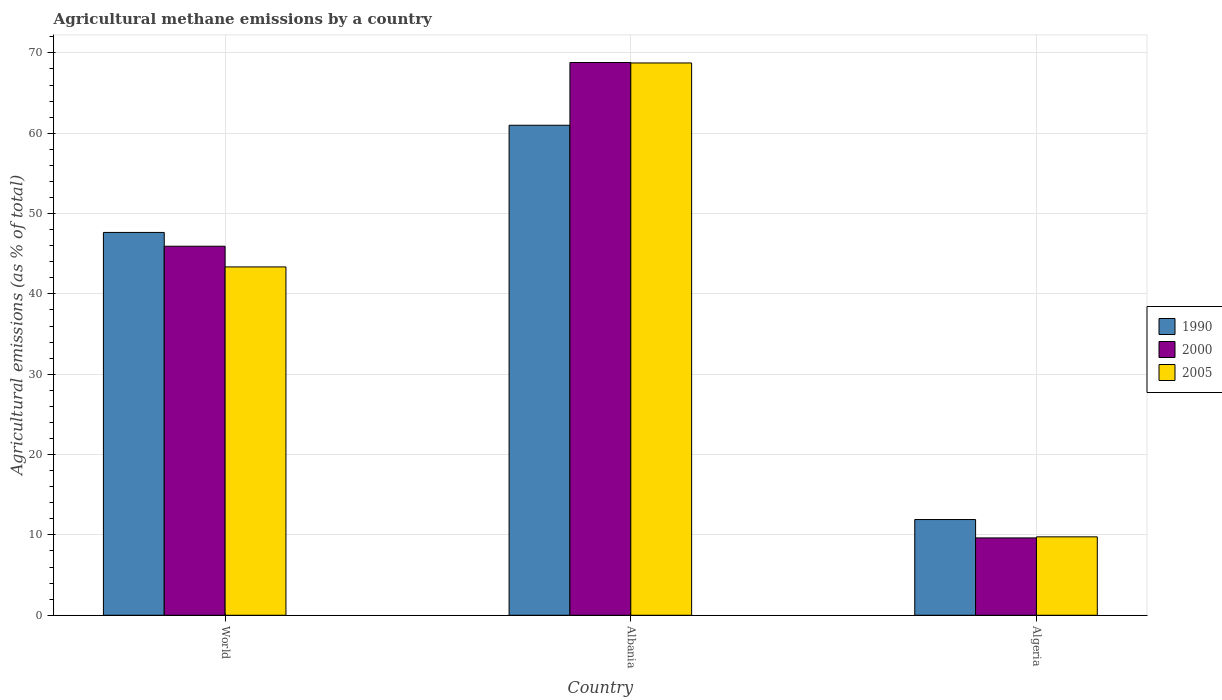How many different coloured bars are there?
Your answer should be very brief. 3. Are the number of bars per tick equal to the number of legend labels?
Provide a succinct answer. Yes. Are the number of bars on each tick of the X-axis equal?
Ensure brevity in your answer.  Yes. How many bars are there on the 1st tick from the left?
Ensure brevity in your answer.  3. How many bars are there on the 1st tick from the right?
Keep it short and to the point. 3. In how many cases, is the number of bars for a given country not equal to the number of legend labels?
Offer a very short reply. 0. What is the amount of agricultural methane emitted in 1990 in Algeria?
Give a very brief answer. 11.91. Across all countries, what is the maximum amount of agricultural methane emitted in 2000?
Your answer should be compact. 68.8. Across all countries, what is the minimum amount of agricultural methane emitted in 2000?
Your answer should be very brief. 9.63. In which country was the amount of agricultural methane emitted in 1990 maximum?
Keep it short and to the point. Albania. In which country was the amount of agricultural methane emitted in 2005 minimum?
Your response must be concise. Algeria. What is the total amount of agricultural methane emitted in 2005 in the graph?
Keep it short and to the point. 121.86. What is the difference between the amount of agricultural methane emitted in 1990 in Algeria and that in World?
Offer a terse response. -35.74. What is the difference between the amount of agricultural methane emitted in 2000 in Albania and the amount of agricultural methane emitted in 2005 in World?
Provide a succinct answer. 25.44. What is the average amount of agricultural methane emitted in 2000 per country?
Provide a succinct answer. 41.45. What is the difference between the amount of agricultural methane emitted of/in 1990 and amount of agricultural methane emitted of/in 2000 in Albania?
Your response must be concise. -7.81. What is the ratio of the amount of agricultural methane emitted in 2000 in Albania to that in Algeria?
Your response must be concise. 7.15. Is the amount of agricultural methane emitted in 2005 in Albania less than that in World?
Make the answer very short. No. What is the difference between the highest and the second highest amount of agricultural methane emitted in 2000?
Offer a terse response. -59.17. What is the difference between the highest and the lowest amount of agricultural methane emitted in 2005?
Give a very brief answer. 58.98. In how many countries, is the amount of agricultural methane emitted in 2005 greater than the average amount of agricultural methane emitted in 2005 taken over all countries?
Your response must be concise. 2. What does the 1st bar from the right in World represents?
Your answer should be very brief. 2005. Are all the bars in the graph horizontal?
Keep it short and to the point. No. How many countries are there in the graph?
Provide a succinct answer. 3. What is the difference between two consecutive major ticks on the Y-axis?
Give a very brief answer. 10. Does the graph contain any zero values?
Make the answer very short. No. How many legend labels are there?
Your answer should be very brief. 3. How are the legend labels stacked?
Offer a very short reply. Vertical. What is the title of the graph?
Provide a short and direct response. Agricultural methane emissions by a country. What is the label or title of the X-axis?
Give a very brief answer. Country. What is the label or title of the Y-axis?
Provide a short and direct response. Agricultural emissions (as % of total). What is the Agricultural emissions (as % of total) of 1990 in World?
Provide a succinct answer. 47.65. What is the Agricultural emissions (as % of total) in 2000 in World?
Your answer should be compact. 45.93. What is the Agricultural emissions (as % of total) in 2005 in World?
Offer a terse response. 43.36. What is the Agricultural emissions (as % of total) in 1990 in Albania?
Offer a very short reply. 60.99. What is the Agricultural emissions (as % of total) in 2000 in Albania?
Keep it short and to the point. 68.8. What is the Agricultural emissions (as % of total) in 2005 in Albania?
Provide a short and direct response. 68.75. What is the Agricultural emissions (as % of total) of 1990 in Algeria?
Make the answer very short. 11.91. What is the Agricultural emissions (as % of total) in 2000 in Algeria?
Keep it short and to the point. 9.63. What is the Agricultural emissions (as % of total) of 2005 in Algeria?
Offer a terse response. 9.76. Across all countries, what is the maximum Agricultural emissions (as % of total) of 1990?
Provide a short and direct response. 60.99. Across all countries, what is the maximum Agricultural emissions (as % of total) in 2000?
Keep it short and to the point. 68.8. Across all countries, what is the maximum Agricultural emissions (as % of total) of 2005?
Make the answer very short. 68.75. Across all countries, what is the minimum Agricultural emissions (as % of total) in 1990?
Keep it short and to the point. 11.91. Across all countries, what is the minimum Agricultural emissions (as % of total) of 2000?
Provide a short and direct response. 9.63. Across all countries, what is the minimum Agricultural emissions (as % of total) in 2005?
Make the answer very short. 9.76. What is the total Agricultural emissions (as % of total) in 1990 in the graph?
Provide a succinct answer. 120.56. What is the total Agricultural emissions (as % of total) in 2000 in the graph?
Your answer should be very brief. 124.36. What is the total Agricultural emissions (as % of total) in 2005 in the graph?
Your answer should be compact. 121.86. What is the difference between the Agricultural emissions (as % of total) in 1990 in World and that in Albania?
Offer a terse response. -13.34. What is the difference between the Agricultural emissions (as % of total) of 2000 in World and that in Albania?
Offer a very short reply. -22.87. What is the difference between the Agricultural emissions (as % of total) of 2005 in World and that in Albania?
Offer a terse response. -25.39. What is the difference between the Agricultural emissions (as % of total) of 1990 in World and that in Algeria?
Provide a succinct answer. 35.74. What is the difference between the Agricultural emissions (as % of total) in 2000 in World and that in Algeria?
Your answer should be very brief. 36.31. What is the difference between the Agricultural emissions (as % of total) of 2005 in World and that in Algeria?
Keep it short and to the point. 33.6. What is the difference between the Agricultural emissions (as % of total) in 1990 in Albania and that in Algeria?
Offer a very short reply. 49.08. What is the difference between the Agricultural emissions (as % of total) in 2000 in Albania and that in Algeria?
Offer a very short reply. 59.17. What is the difference between the Agricultural emissions (as % of total) of 2005 in Albania and that in Algeria?
Your response must be concise. 58.98. What is the difference between the Agricultural emissions (as % of total) in 1990 in World and the Agricultural emissions (as % of total) in 2000 in Albania?
Provide a short and direct response. -21.15. What is the difference between the Agricultural emissions (as % of total) in 1990 in World and the Agricultural emissions (as % of total) in 2005 in Albania?
Your response must be concise. -21.09. What is the difference between the Agricultural emissions (as % of total) in 2000 in World and the Agricultural emissions (as % of total) in 2005 in Albania?
Ensure brevity in your answer.  -22.81. What is the difference between the Agricultural emissions (as % of total) in 1990 in World and the Agricultural emissions (as % of total) in 2000 in Algeria?
Your response must be concise. 38.02. What is the difference between the Agricultural emissions (as % of total) in 1990 in World and the Agricultural emissions (as % of total) in 2005 in Algeria?
Keep it short and to the point. 37.89. What is the difference between the Agricultural emissions (as % of total) in 2000 in World and the Agricultural emissions (as % of total) in 2005 in Algeria?
Provide a succinct answer. 36.17. What is the difference between the Agricultural emissions (as % of total) in 1990 in Albania and the Agricultural emissions (as % of total) in 2000 in Algeria?
Give a very brief answer. 51.36. What is the difference between the Agricultural emissions (as % of total) in 1990 in Albania and the Agricultural emissions (as % of total) in 2005 in Algeria?
Your answer should be compact. 51.23. What is the difference between the Agricultural emissions (as % of total) of 2000 in Albania and the Agricultural emissions (as % of total) of 2005 in Algeria?
Ensure brevity in your answer.  59.04. What is the average Agricultural emissions (as % of total) of 1990 per country?
Your answer should be compact. 40.19. What is the average Agricultural emissions (as % of total) in 2000 per country?
Your answer should be compact. 41.45. What is the average Agricultural emissions (as % of total) of 2005 per country?
Keep it short and to the point. 40.62. What is the difference between the Agricultural emissions (as % of total) in 1990 and Agricultural emissions (as % of total) in 2000 in World?
Provide a succinct answer. 1.72. What is the difference between the Agricultural emissions (as % of total) of 1990 and Agricultural emissions (as % of total) of 2005 in World?
Make the answer very short. 4.29. What is the difference between the Agricultural emissions (as % of total) of 2000 and Agricultural emissions (as % of total) of 2005 in World?
Give a very brief answer. 2.58. What is the difference between the Agricultural emissions (as % of total) of 1990 and Agricultural emissions (as % of total) of 2000 in Albania?
Give a very brief answer. -7.81. What is the difference between the Agricultural emissions (as % of total) in 1990 and Agricultural emissions (as % of total) in 2005 in Albania?
Offer a very short reply. -7.75. What is the difference between the Agricultural emissions (as % of total) of 2000 and Agricultural emissions (as % of total) of 2005 in Albania?
Give a very brief answer. 0.06. What is the difference between the Agricultural emissions (as % of total) in 1990 and Agricultural emissions (as % of total) in 2000 in Algeria?
Keep it short and to the point. 2.29. What is the difference between the Agricultural emissions (as % of total) in 1990 and Agricultural emissions (as % of total) in 2005 in Algeria?
Provide a short and direct response. 2.15. What is the difference between the Agricultural emissions (as % of total) of 2000 and Agricultural emissions (as % of total) of 2005 in Algeria?
Offer a terse response. -0.13. What is the ratio of the Agricultural emissions (as % of total) of 1990 in World to that in Albania?
Your answer should be compact. 0.78. What is the ratio of the Agricultural emissions (as % of total) of 2000 in World to that in Albania?
Provide a succinct answer. 0.67. What is the ratio of the Agricultural emissions (as % of total) in 2005 in World to that in Albania?
Keep it short and to the point. 0.63. What is the ratio of the Agricultural emissions (as % of total) of 1990 in World to that in Algeria?
Your answer should be very brief. 4. What is the ratio of the Agricultural emissions (as % of total) in 2000 in World to that in Algeria?
Ensure brevity in your answer.  4.77. What is the ratio of the Agricultural emissions (as % of total) in 2005 in World to that in Algeria?
Make the answer very short. 4.44. What is the ratio of the Agricultural emissions (as % of total) of 1990 in Albania to that in Algeria?
Offer a terse response. 5.12. What is the ratio of the Agricultural emissions (as % of total) in 2000 in Albania to that in Algeria?
Your answer should be compact. 7.15. What is the ratio of the Agricultural emissions (as % of total) of 2005 in Albania to that in Algeria?
Your answer should be very brief. 7.04. What is the difference between the highest and the second highest Agricultural emissions (as % of total) in 1990?
Keep it short and to the point. 13.34. What is the difference between the highest and the second highest Agricultural emissions (as % of total) in 2000?
Keep it short and to the point. 22.87. What is the difference between the highest and the second highest Agricultural emissions (as % of total) in 2005?
Your answer should be very brief. 25.39. What is the difference between the highest and the lowest Agricultural emissions (as % of total) of 1990?
Offer a terse response. 49.08. What is the difference between the highest and the lowest Agricultural emissions (as % of total) of 2000?
Give a very brief answer. 59.17. What is the difference between the highest and the lowest Agricultural emissions (as % of total) in 2005?
Provide a short and direct response. 58.98. 